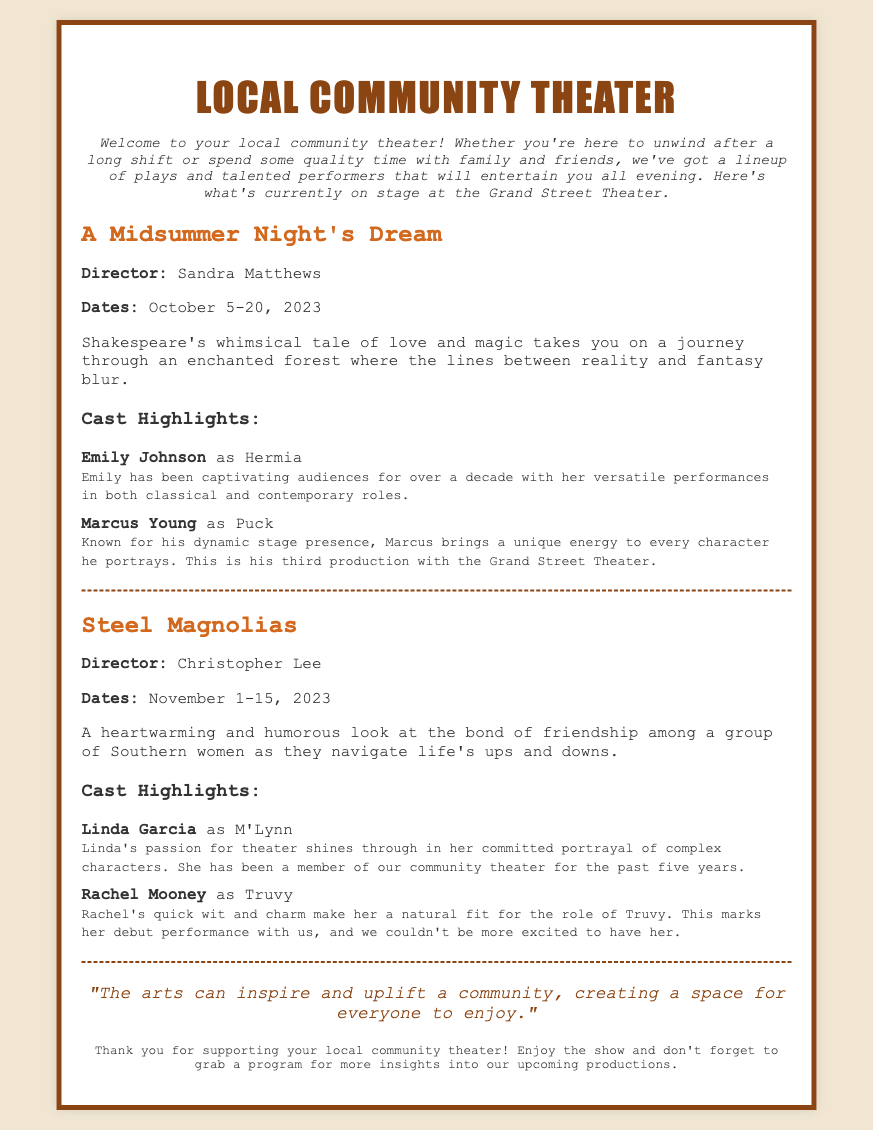What is the title of the first production? The first production is identified in the document as "A Midsummer Night's Dream."
Answer: A Midsummer Night's Dream Who is the director of Steel Magnolias? The document states that Christopher Lee is the director of Steel Magnolias.
Answer: Christopher Lee What are the dates for A Midsummer Night's Dream? A Midsummer Night's Dream is scheduled from October 5 to October 20, 2023.
Answer: October 5-20, 2023 How many years has Linda Garcia been a member of the community theater? The document mentions that Linda Garcia has been a member of the community theater for the past five years.
Answer: Five years Which actor is making their debut performance with the theater? According to the document, Rachel Mooney is making her debut performance with the theater.
Answer: Rachel Mooney What is the theme of Steel Magnolias? Steel Magnolias is described as a heartwarming and humorous look at the bond of friendship among a group of Southern women.
Answer: Friendship What is the quote mentioned in the Playbill? The quote states, "The arts can inspire and uplift a community, creating a space for everyone to enjoy."
Answer: The arts can inspire and uplift a community, creating a space for everyone to enjoy How many productions are currently highlighted in the Playbill? The document highlights two productions currently taking place.
Answer: Two productions What is the name of the theater mentioned in the document? The document refers to the theater as the Grand Street Theater.
Answer: Grand Street Theater 